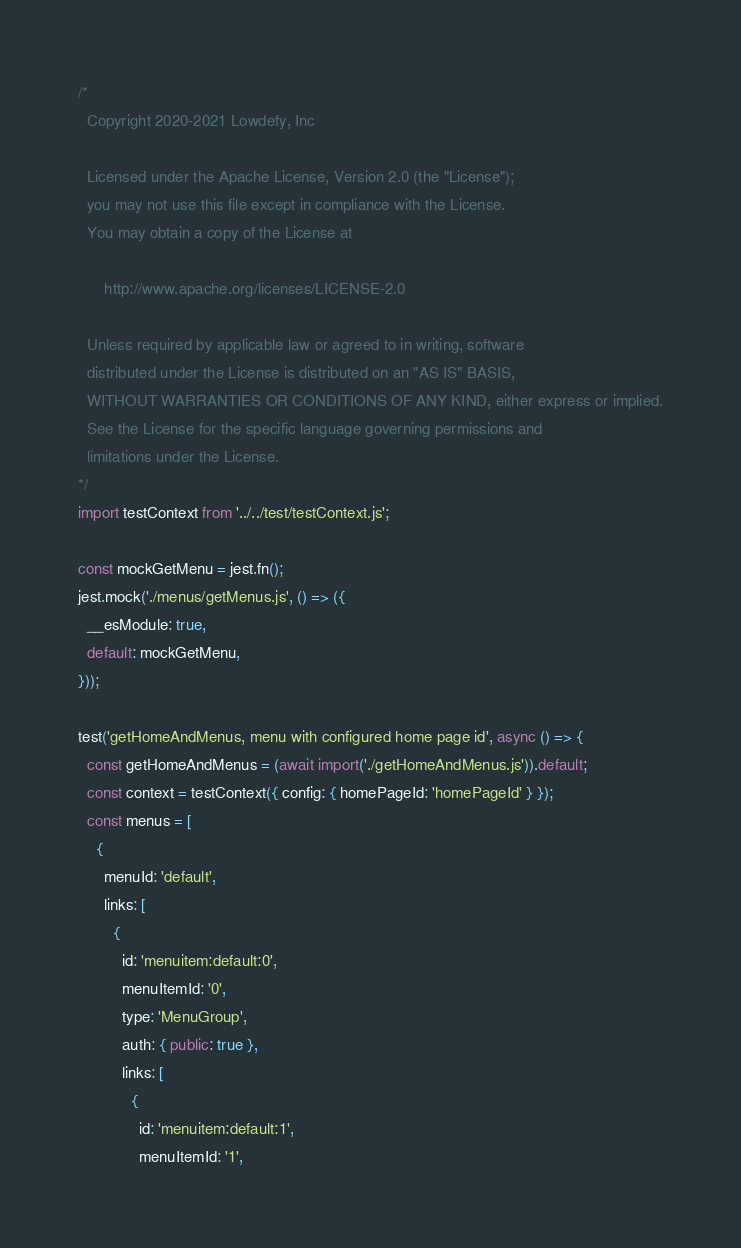Convert code to text. <code><loc_0><loc_0><loc_500><loc_500><_JavaScript_>/*
  Copyright 2020-2021 Lowdefy, Inc

  Licensed under the Apache License, Version 2.0 (the "License");
  you may not use this file except in compliance with the License.
  You may obtain a copy of the License at

      http://www.apache.org/licenses/LICENSE-2.0

  Unless required by applicable law or agreed to in writing, software
  distributed under the License is distributed on an "AS IS" BASIS,
  WITHOUT WARRANTIES OR CONDITIONS OF ANY KIND, either express or implied.
  See the License for the specific language governing permissions and
  limitations under the License.
*/
import testContext from '../../test/testContext.js';

const mockGetMenu = jest.fn();
jest.mock('./menus/getMenus.js', () => ({
  __esModule: true,
  default: mockGetMenu,
}));

test('getHomeAndMenus, menu with configured home page id', async () => {
  const getHomeAndMenus = (await import('./getHomeAndMenus.js')).default;
  const context = testContext({ config: { homePageId: 'homePageId' } });
  const menus = [
    {
      menuId: 'default',
      links: [
        {
          id: 'menuitem:default:0',
          menuItemId: '0',
          type: 'MenuGroup',
          auth: { public: true },
          links: [
            {
              id: 'menuitem:default:1',
              menuItemId: '1',</code> 